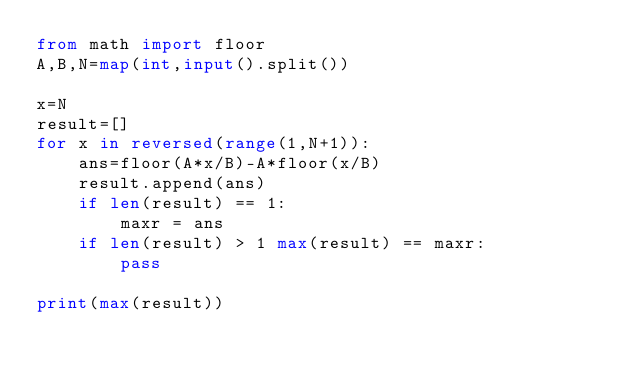<code> <loc_0><loc_0><loc_500><loc_500><_Python_>from math import floor
A,B,N=map(int,input().split())

x=N
result=[]
for x in reversed(range(1,N+1)):
    ans=floor(A*x/B)-A*floor(x/B)
    result.append(ans)
    if len(result) == 1:
        maxr = ans 
    if len(result) > 1 max(result) == maxr:
        pass

print(max(result))
</code> 